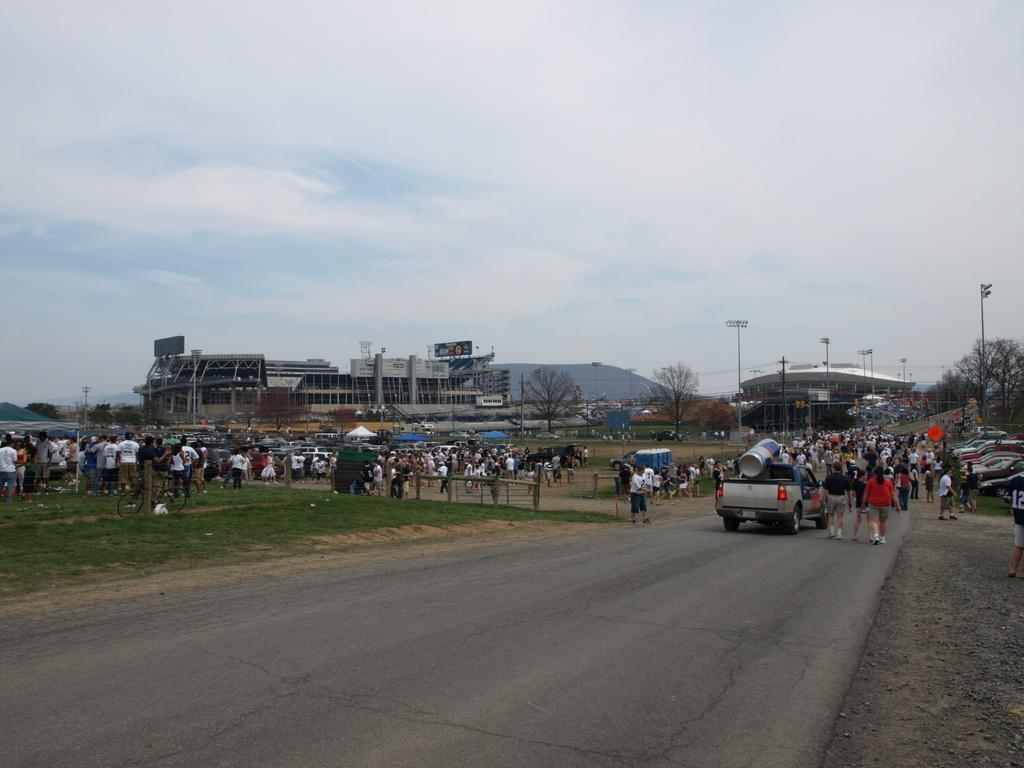What is the main subject of the image? There is a vehicle in the image. Can you describe the people in the image? There are persons in the image. What type of artificial lighting can be seen in the image? There are street lights in the image. What type of natural vegetation is present in the image? There are trees in the image. What type of man-made structures are visible in the image? There are buildings in the image. What type of temporary shelter is present in the image? There are tents in the image. What type of ground surface is visible in the image? There is grass in the image. What type of natural landform is present in the image? There is a hill in the image. What part of the natural environment is visible in the image? The sky is visible in the image. What type of atmospheric phenomenon can be seen in the sky? There are clouds in the image. What type of vegetable is being used as a hat in the image? There is no vegetable being used as a hat in the image. What type of curve can be seen in the image? There is no curve mentioned or visible in the image. 